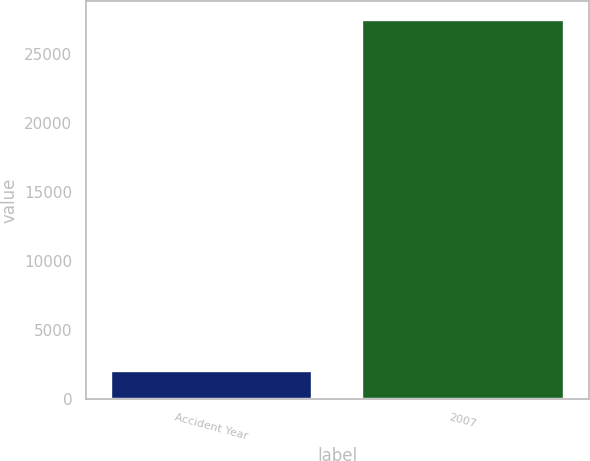Convert chart to OTSL. <chart><loc_0><loc_0><loc_500><loc_500><bar_chart><fcel>Accident Year<fcel>2007<nl><fcel>2010<fcel>27445<nl></chart> 